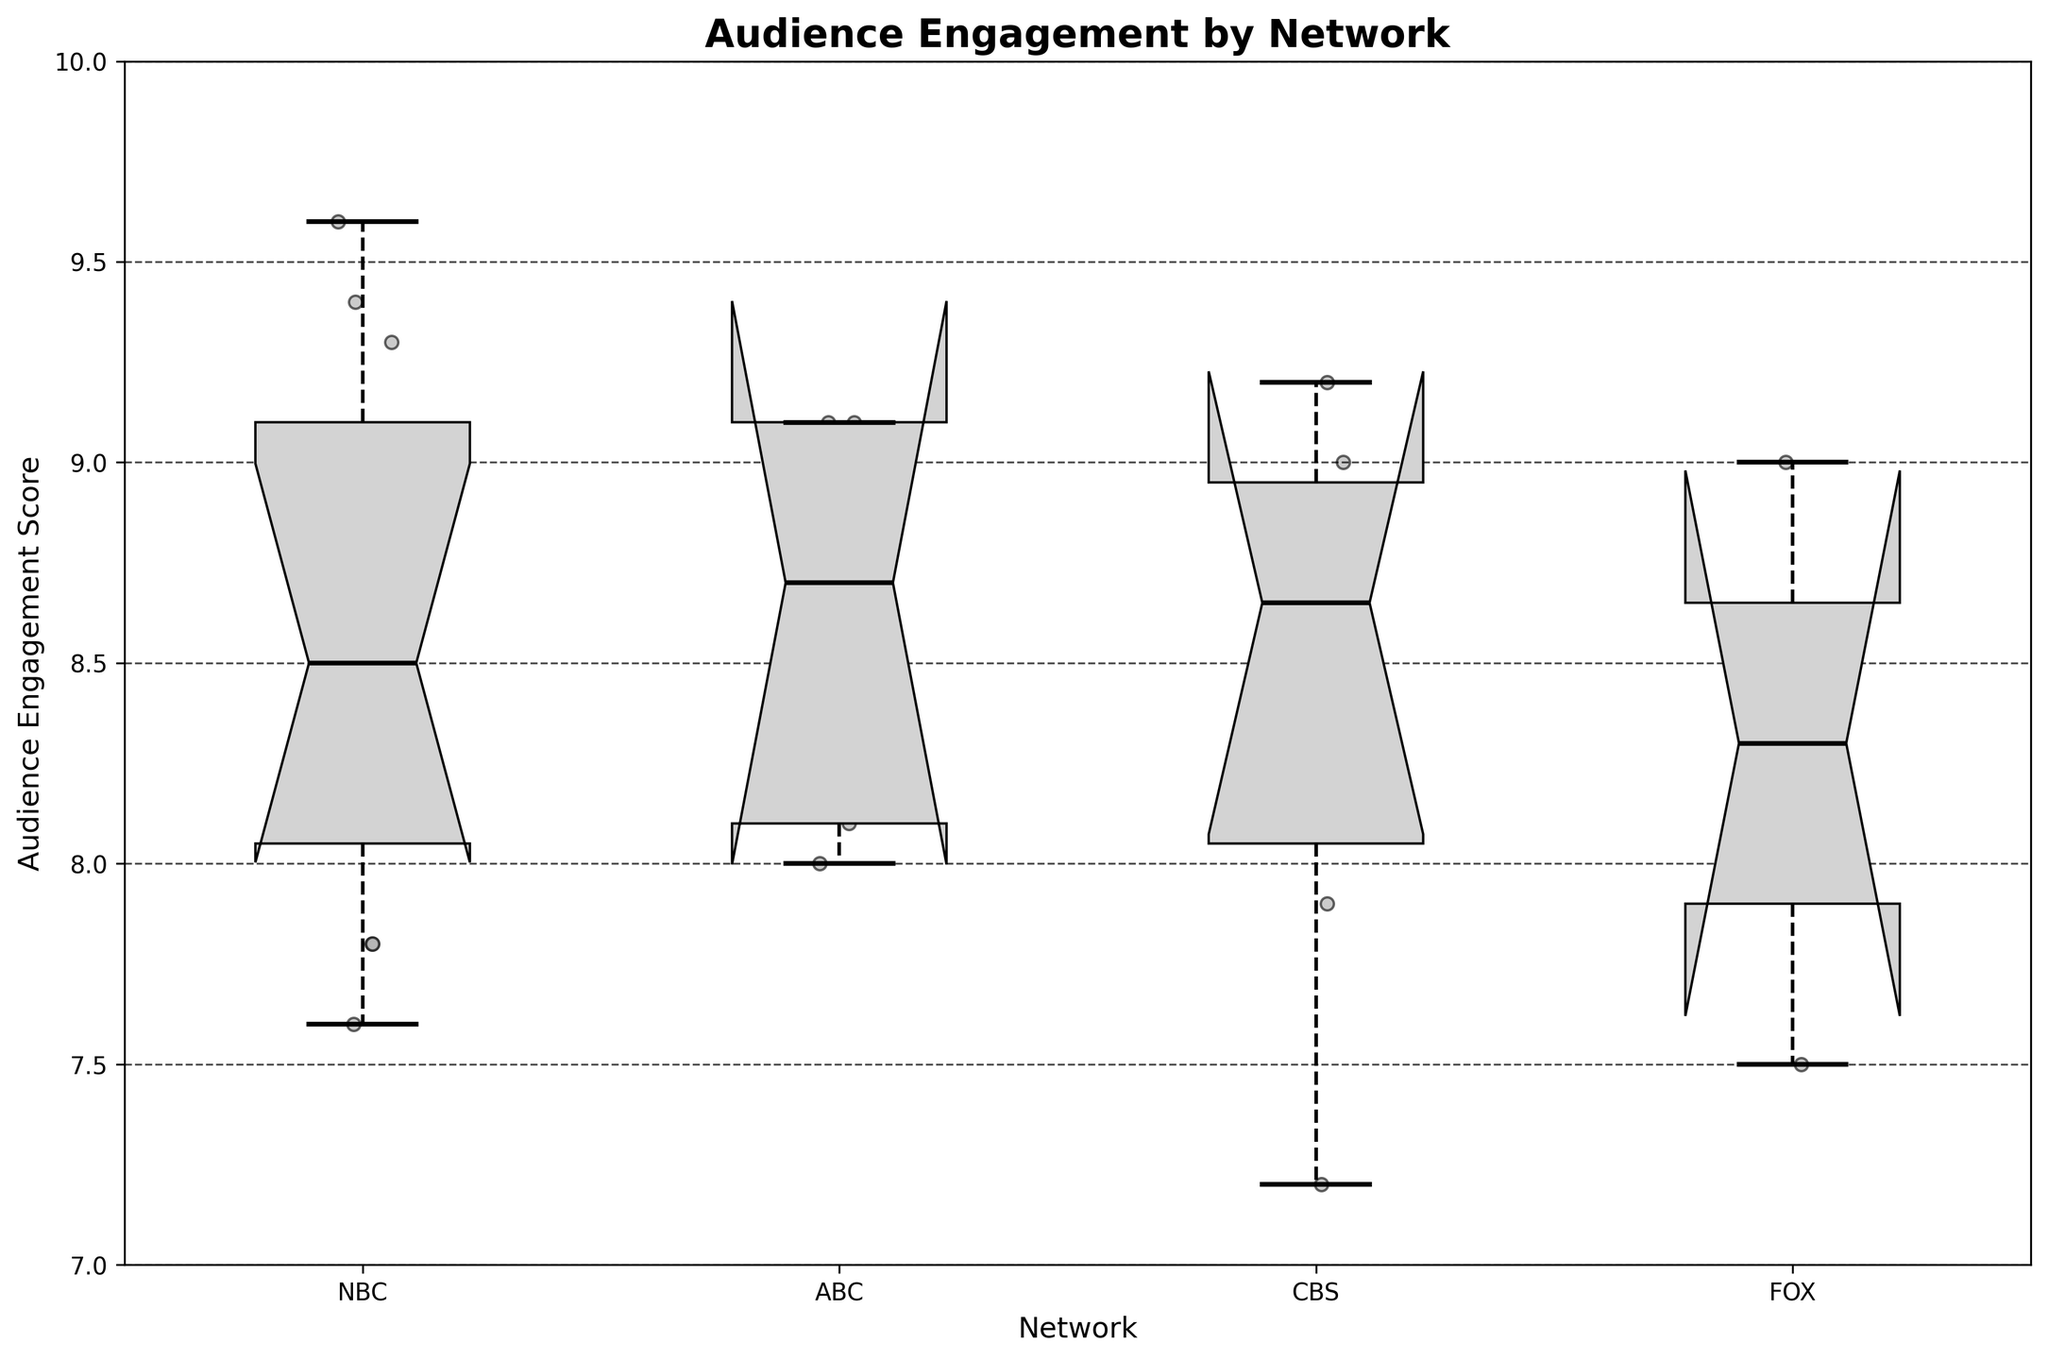How many networks are compared in the figure? The figure compares the audience engagement across different networks. By looking at the x-axis labels, we can count the distinct networks represented.
Answer: 4 Which network has the highest median audience engagement? To find the network with the highest median audience engagement, look at the central line inside each box, which represents the median. Identify which of these lines is positioned the highest along the vertical axis.
Answer: CBS What is the range of audience engagement scores for NBC? The range is determined by the distance between the lowest whisker and the highest whisker. For NBC, locate the bottom and top whiskers and find the difference.
Answer: 7.2 to 9.6 Which network has the greatest spread in audience engagement scores? The spread can be identified by comparing the length of the boxes and whiskers. The network with the longest total length from the bottom whisker to the top whisker has the greatest spread.
Answer: FOX Are there any outliers for ABC? Outliers are typically marked by points outside the whiskers. Check the ABC boxplot to see if there are any points that fall outside the whisker range.
Answer: No Which network has the smallest interquartile range (IQR) of audience engagement? The IQR is represented by the height of the box itself, which shows the middle 50% of data. Identify which box is the shortest.
Answer: ABC How does the audience engagement for NBC compare to CBS? To compare, examine the position of the medians and the notches in the boxplots. See which network has a higher median and tighter notches (indicating less variability).
Answer: NBC has a wider range, CBS has a higher median Do the notches of any two networks overlap? Notches indicate confidence intervals around the medians. Check if the notches of any networks intersect, suggesting their medians are not significantly different.
Answer: Yes, NBC and CBS Which decade had the highest overall audience engagement scores? This question requires analyzing the scatter plot overlay. Count or estimate which decade's scatter points tend to be higher on the y-axis across all networks.
Answer: 1990s What is the difference between the highest and lowest median audience engagement scores? Identify the highest and lowest median lines across all boxplots, then calculate the difference between these two values.
Answer: 9.2 - 8.0 = 1.2 